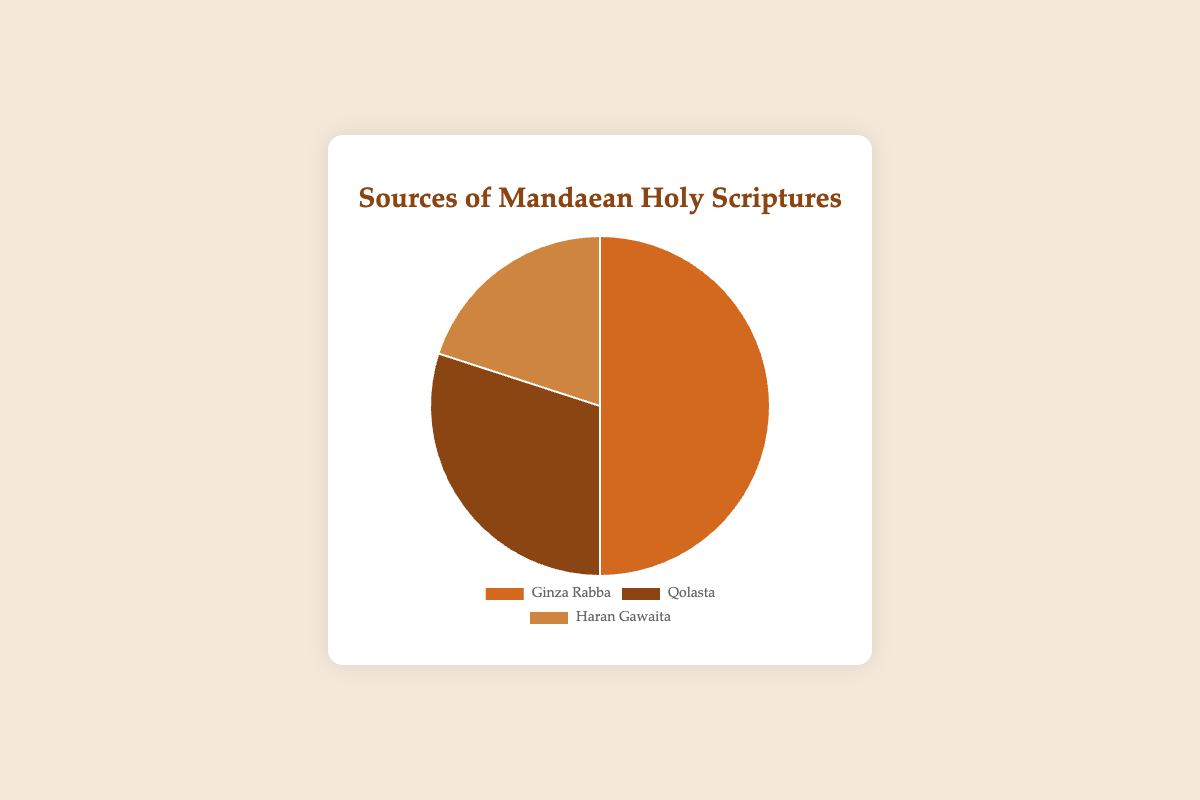Which source contributes the highest percentage to the Mandaean Holy Scriptures? By examining the pie chart, we identify and compare the sources. The largest section is labeled "Ginza Rabba" with a percentage of 50%.
Answer: Ginza Rabba Which source has the lowest contribution to the Mandaean Holy Scriptures? We look for the smallest segment in the pie chart, which is labeled "Haran Gawaita" at 20%.
Answer: Haran Gawaita What is the combined percentage contribution of the Qolasta and Haran Gawaita sources? Add the percentages of Qolasta (30%) and Haran Gawaita (20%): 30% + 20% = 50%.
Answer: 50% How much more does Ginza Rabba contribute compared to Haran Gawaita? Subtract the percentage of Haran Gawaita (20%) from Ginza Rabba (50%): 50% - 20% = 30%.
Answer: 30% What fraction of the Mandaean Holy Scriptures comes from Qolasta? Qolasta accounts for 30% of the total. To convert this to a fraction, we have 30/100, which simplifies to 3/10.
Answer: 3/10 Which two sources together contribute the majority of the Mandaean Holy Scriptures? We must find a pair of sources whose combined percentage is over 50%. Ginza Rabba (50%) and any other source already exceed 50%. Alternatively, Qolasta (30%) and Haran Gawaita (20%) add up to 50%, but not more than 50%. Thus, Ginza Rabba and any other source contribute the majority.
Answer: Ginza Rabba and any other source If the percentage of Qolasta was reduced by one-third, how would its new contribution compare to Haran Gawaita? One-third of Qolasta's 30% is 10%. Reducing Qolasta by 10% results in 20%. Since Haran Gawaita also contributes 20%, they would then be equal.
Answer: Equal What is the difference in percentage contribution between the largest and smallest sources? Subtract the percentage of the smallest source, Haran Gawaita (20%), from the largest source, Ginza Rabba (50%): 50% - 20% = 30%.
Answer: 30% What is the average percentage contribution of the three sources? Add the percentages of all three sources: 50% (Ginza Rabba) + 30% (Qolasta) + 20% (Haran Gawaita) = 100%. Divide by 3: 100%/3 = approximately 33.33%.
Answer: 33.33% Which sources combined contribute the same percentage as Ginza Rabba alone? Combine the percentages of Qolasta (30%) and Haran Gawaita (20%): 30% + 20% = 50%. This matches the contribution of Ginza Rabba.
Answer: Qolasta and Haran Gawaita 